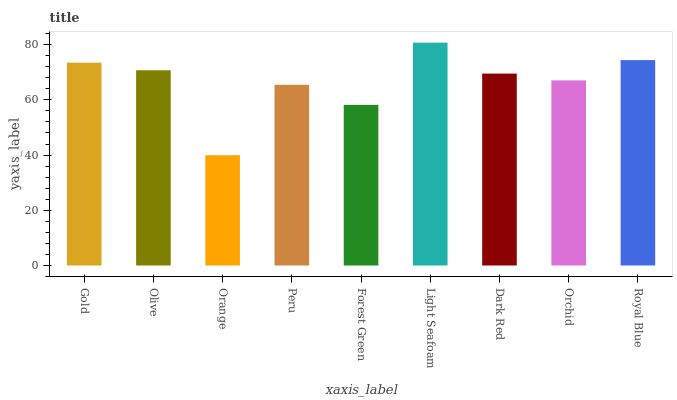Is Orange the minimum?
Answer yes or no. Yes. Is Light Seafoam the maximum?
Answer yes or no. Yes. Is Olive the minimum?
Answer yes or no. No. Is Olive the maximum?
Answer yes or no. No. Is Gold greater than Olive?
Answer yes or no. Yes. Is Olive less than Gold?
Answer yes or no. Yes. Is Olive greater than Gold?
Answer yes or no. No. Is Gold less than Olive?
Answer yes or no. No. Is Dark Red the high median?
Answer yes or no. Yes. Is Dark Red the low median?
Answer yes or no. Yes. Is Olive the high median?
Answer yes or no. No. Is Gold the low median?
Answer yes or no. No. 